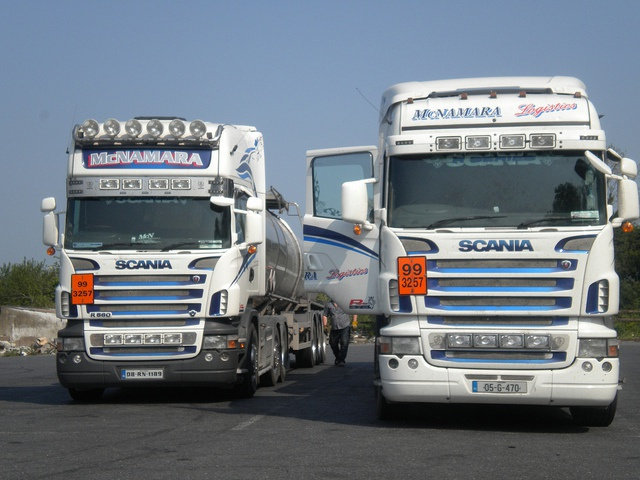Describe the objects in this image and their specific colors. I can see truck in gray, lightgray, darkgray, and black tones, truck in gray, black, lightgray, and darkgray tones, and people in gray, black, and salmon tones in this image. 